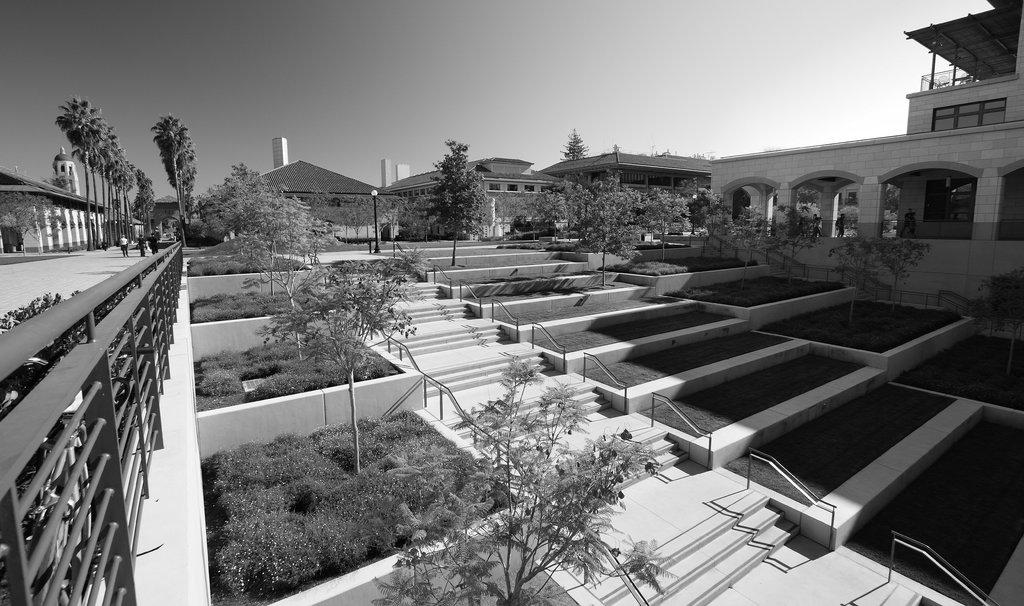What type of living organisms can be seen in the image? Plants and trees are visible in the image. What architectural features are present in the image? Fences, steps, and buildings are present in the image. What is the purpose of the light poles in the image? The light poles are likely for illuminating the area at night. What are the people in the image doing? The people are walking on a path in the image. What is visible in the background of the image? The sky is visible in the background of the image. Can you tell me how many ears are visible on the people in the image? There is no way to determine the number of ears visible on the people in the image, as their ears are not visible in the image. What type of alarm is going off in the image? There is no alarm present in the image. 